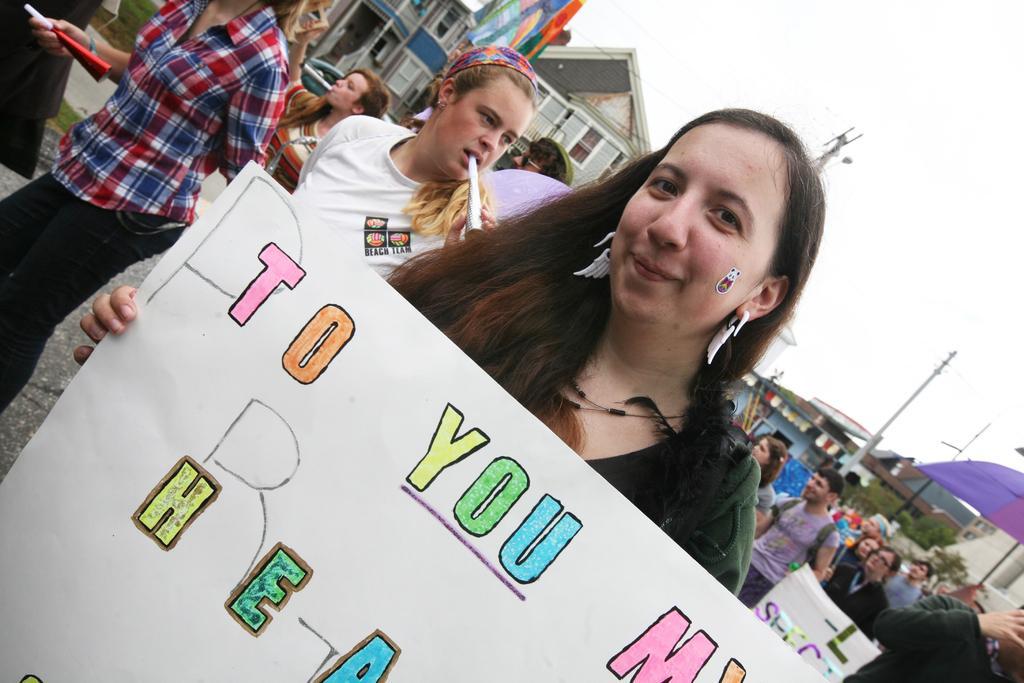Describe this image in one or two sentences. In the center of the image there is a woman holding a placard. In the background of the image there are people walking. There are houses. There are electric poles and sky. 